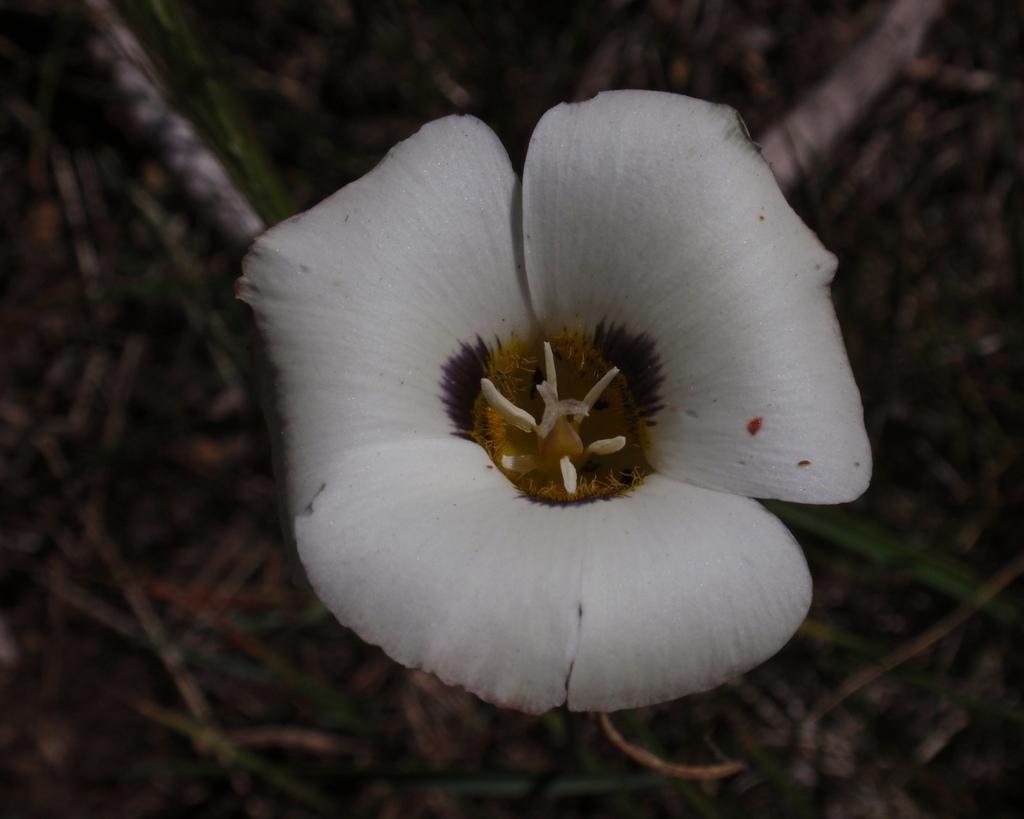Please provide a concise description of this image. In this image there is a flower which is in white color. Background there are plants on the land. 